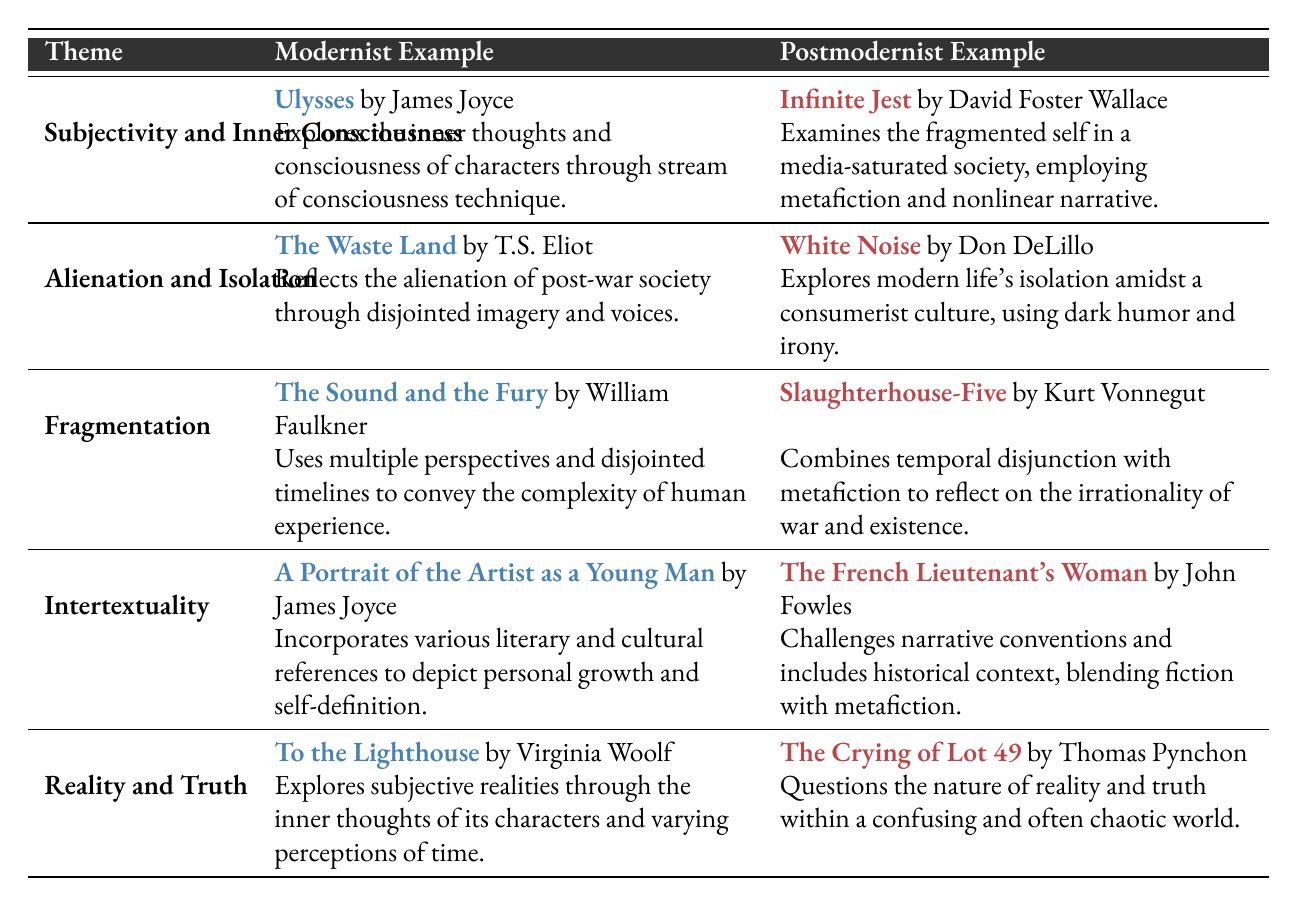What is the modernist example for the theme "Alienation and Isolation"? The table shows that the modernist example for the theme "Alienation and Isolation" is "The Waste Land" by T.S. Eliot.
Answer: The Waste Land by T.S. Eliot Who wrote "Infinite Jest"? According to the table, "Infinite Jest" was written by David Foster Wallace.
Answer: David Foster Wallace Is "The Crying of Lot 49" a modernist work? "The Crying of Lot 49" is listed under the postmodernist examples in the table, indicating it is not a modernist work.
Answer: No Which work addresses the theme of "Reality and Truth"? The table indicates that "To the Lighthouse" by Virginia Woolf addresses the theme of "Reality and Truth" in the modernist column.
Answer: To the Lighthouse by Virginia Woolf Identify one significant narrative technique used in the postmodernist example for "Subjectivity and Inner Consciousness." The table states that "Infinite Jest" employs metafiction and nonlinear narrative, which are significant narrative techniques in the postmodernist example for this theme.
Answer: Metafiction and nonlinear narrative What is the description associated with "The Sound and the Fury"? The description associated with "The Sound and the Fury" states that it uses multiple perspectives and disjointed timelines to convey the complexity of human experience.
Answer: Uses multiple perspectives and disjointed timelines Count how many themes listed in the table involve the concept of "fragmentation." The table contains two themes related to fragmentation: "Fragmentation" itself and the description of "Infinite Jest," which explores the fragmented self. Thus, there are two relevant themes.
Answer: 2 Which author's work reflects on alienation through dark humor? "White Noise" by Don DeLillo is the work referenced in the table that reflects modern life's isolation using dark humor and irony.
Answer: Don DeLillo Does "A Portrait of the Artist as a Young Man" include intertextuality? The information in the table indicates that "A Portrait of the Artist as a Young Man" incorporates various literary and cultural references, confirming that it does include intertextuality.
Answer: Yes 